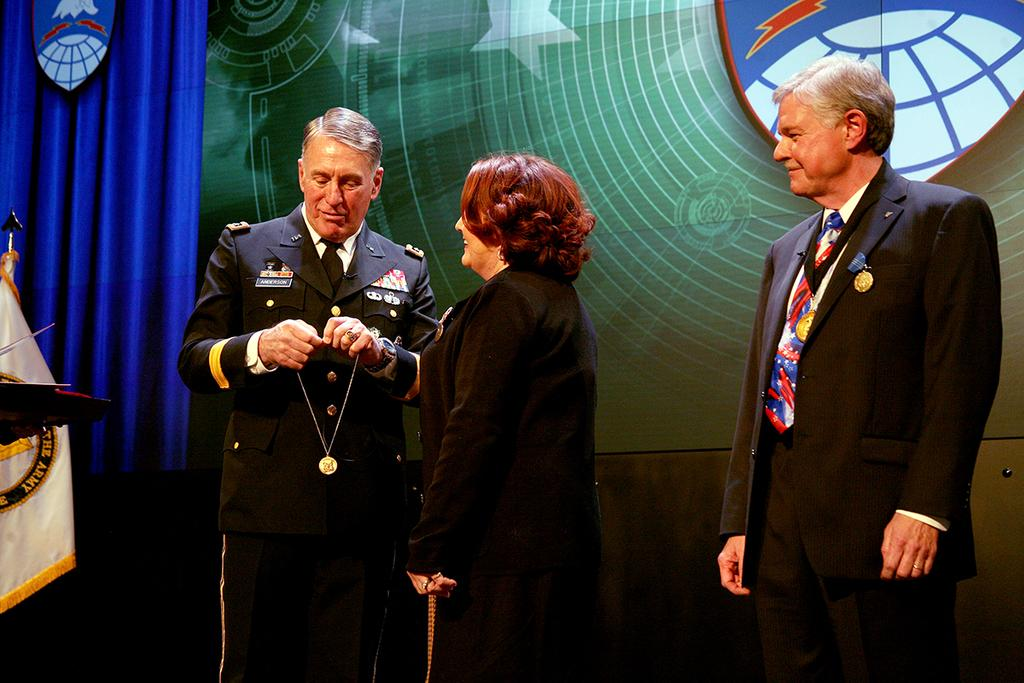How many people are in the image? There is a group of people in the image. Can you describe the woman in the middle of the image? The woman in the middle of the image is smiling. What can be seen in the background of the image? There is a flag, curtains, and a hoarding in the background of the image. What type of pets are visible in the image? There are no pets visible in the image. What happened to the van in the aftermath of the event? There is no van or event mentioned in the image, so it is not possible to answer that question. 